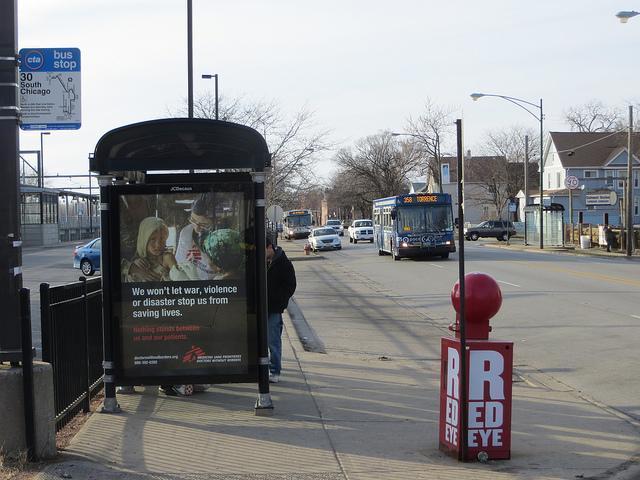How many people can you see?
Give a very brief answer. 3. 